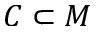<formula> <loc_0><loc_0><loc_500><loc_500>C \subset M</formula> 